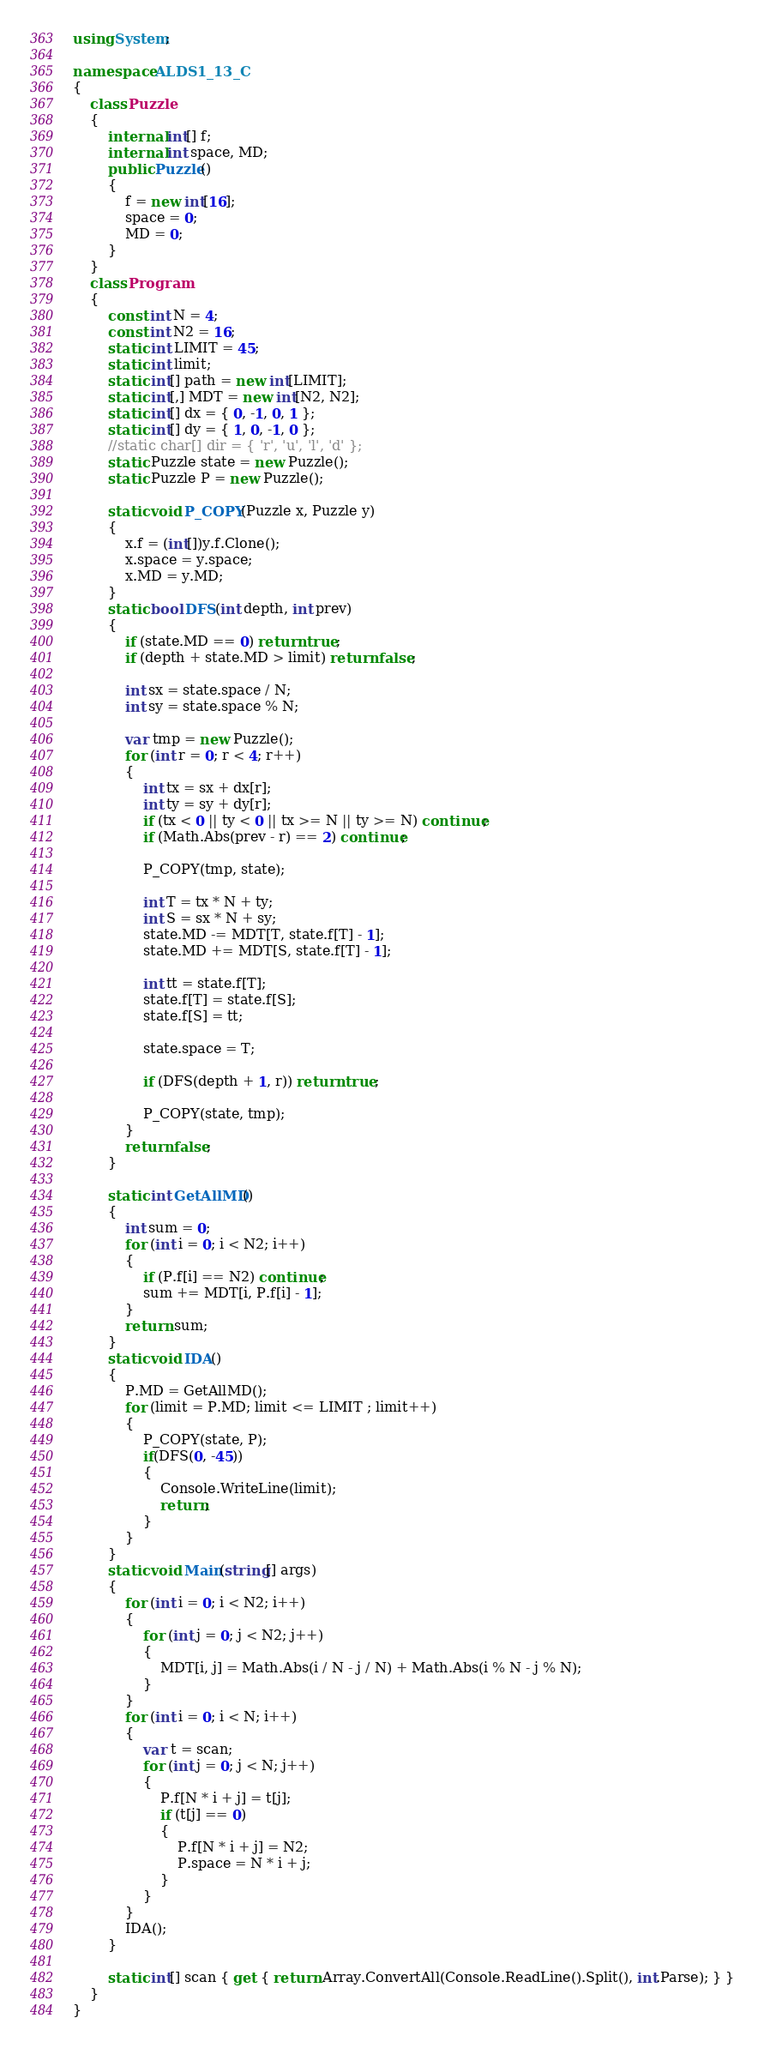<code> <loc_0><loc_0><loc_500><loc_500><_C#_>using System;

namespace ALDS1_13_C
{
    class Puzzle
    {
        internal int[] f;
        internal int space, MD;
        public Puzzle()
        {
            f = new int[16];
            space = 0;
            MD = 0;
        }
    }
    class Program
    {
        const int N = 4;
        const int N2 = 16;
        static int LIMIT = 45;
        static int limit;
        static int[] path = new int[LIMIT];
        static int[,] MDT = new int[N2, N2];
        static int[] dx = { 0, -1, 0, 1 };
        static int[] dy = { 1, 0, -1, 0 };
        //static char[] dir = { 'r', 'u', 'l', 'd' };
        static Puzzle state = new Puzzle();
        static Puzzle P = new Puzzle();

        static void P_COPY(Puzzle x, Puzzle y)
        {
            x.f = (int[])y.f.Clone();
            x.space = y.space;
            x.MD = y.MD;
        }
        static bool DFS(int depth, int prev)
        {
            if (state.MD == 0) return true;
            if (depth + state.MD > limit) return false;

            int sx = state.space / N;
            int sy = state.space % N;

            var tmp = new Puzzle();
            for (int r = 0; r < 4; r++)
            {
                int tx = sx + dx[r];
                int ty = sy + dy[r];
                if (tx < 0 || ty < 0 || tx >= N || ty >= N) continue;
                if (Math.Abs(prev - r) == 2) continue;

                P_COPY(tmp, state);

                int T = tx * N + ty;
                int S = sx * N + sy;
                state.MD -= MDT[T, state.f[T] - 1];
                state.MD += MDT[S, state.f[T] - 1];

                int tt = state.f[T];
                state.f[T] = state.f[S];
                state.f[S] = tt;

                state.space = T;

                if (DFS(depth + 1, r)) return true;
  
                P_COPY(state, tmp);
            }
            return false;
        }
   
        static int GetAllMD()
        {
            int sum = 0;
            for (int i = 0; i < N2; i++)
            {
                if (P.f[i] == N2) continue;
                sum += MDT[i, P.f[i] - 1];
            }
            return sum;
        }
        static void IDA()
        {
            P.MD = GetAllMD();
            for (limit = P.MD; limit <= LIMIT ; limit++)
            {
                P_COPY(state, P);
                if(DFS(0, -45))
                {
                    Console.WriteLine(limit);
                    return;
                }
            }
        }
        static void Main(string[] args)
        {
            for (int i = 0; i < N2; i++)
            {
                for (int j = 0; j < N2; j++)
                {
                    MDT[i, j] = Math.Abs(i / N - j / N) + Math.Abs(i % N - j % N);
                }
            }       
            for (int i = 0; i < N; i++)
            {
                var t = scan;
                for (int j = 0; j < N; j++)
                {
                    P.f[N * i + j] = t[j];
                    if (t[j] == 0)
                    {
                        P.f[N * i + j] = N2;
                        P.space = N * i + j;
                    }
                }               
            }
            IDA();
        }
      
        static int[] scan { get { return Array.ConvertAll(Console.ReadLine().Split(), int.Parse); } }
    }
}</code> 